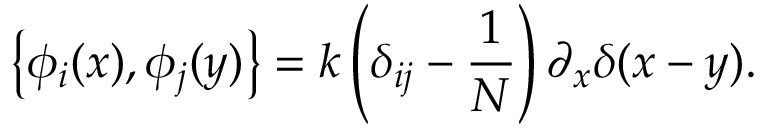Convert formula to latex. <formula><loc_0><loc_0><loc_500><loc_500>\left \{ \phi _ { i } ( x ) , \phi _ { j } ( y ) \right \} = k \left ( \delta _ { i j } - \frac { 1 } { N } \right ) \partial _ { x } \delta ( x - y ) .</formula> 